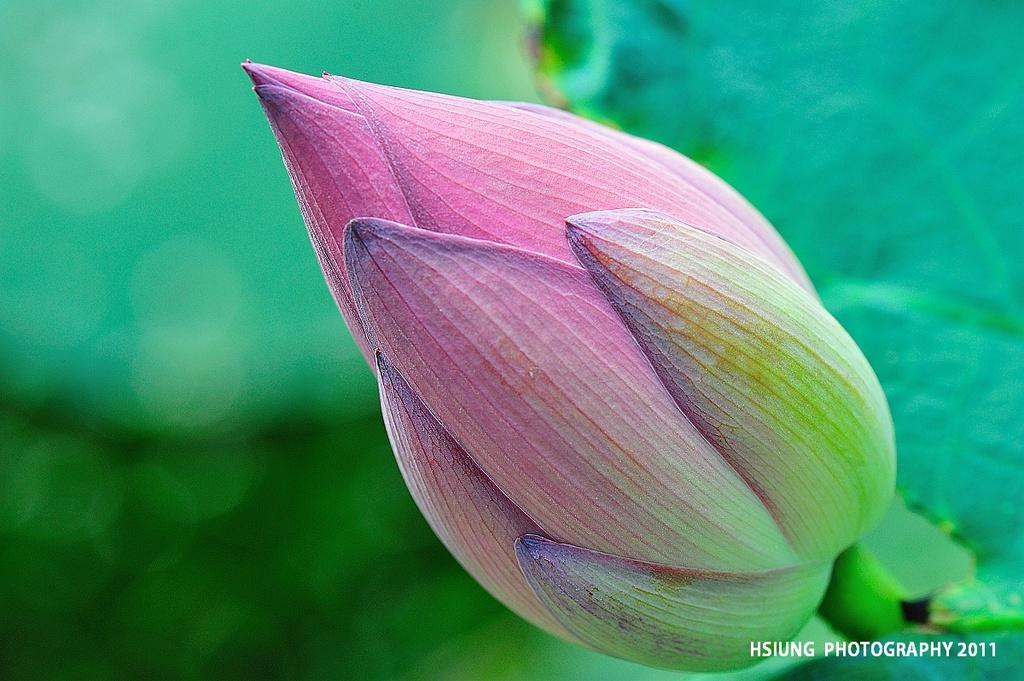What is the main subject of the image? There is a bus in the image. What colors are used to paint the bus? The bus is pink and green in color. What type of vegetation can be seen in the image? There are green leaves in the image. Can you describe any additional features of the image? There is a watermark in the image, and the background is blurred. What type of structure is being argued about in the image? There is no structure or argument present in the image; it features a pink and green bus with green leaves and a blurred background. 